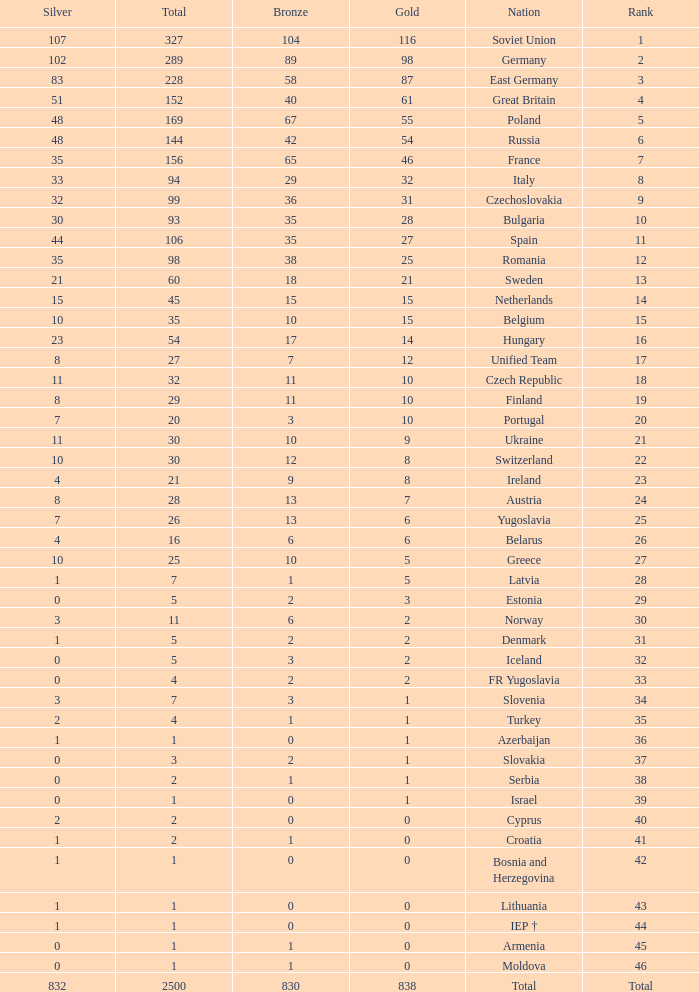What is the rank of the nation with more than 0 silver medals and 38 bronze medals? 12.0. 